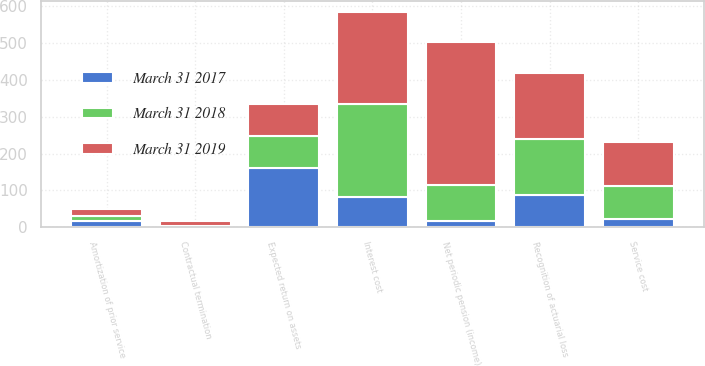Convert chart to OTSL. <chart><loc_0><loc_0><loc_500><loc_500><stacked_bar_chart><ecel><fcel>Service cost<fcel>Interest cost<fcel>Expected return on assets<fcel>Amortization of prior service<fcel>Contractual termination<fcel>Recognition of actuarial loss<fcel>Net periodic pension (income)<nl><fcel>March 31 2018<fcel>88<fcel>253<fcel>87<fcel>15<fcel>3<fcel>153<fcel>98<nl><fcel>March 31 2019<fcel>121<fcel>249<fcel>87<fcel>18<fcel>13<fcel>178<fcel>388<nl><fcel>March 31 2017<fcel>23<fcel>82<fcel>161<fcel>17<fcel>1<fcel>87<fcel>16<nl></chart> 